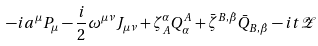<formula> <loc_0><loc_0><loc_500><loc_500>- i a ^ { \mu } P _ { \mu } - \frac { i } { 2 } \omega ^ { \mu \nu } J _ { \mu \nu } + \zeta _ { A } ^ { \alpha } Q ^ { A } _ { \alpha } + \bar { \zeta } ^ { B , \dot { \beta } } \bar { Q } _ { B , \dot { \beta } } - i t \mathcal { Z }</formula> 